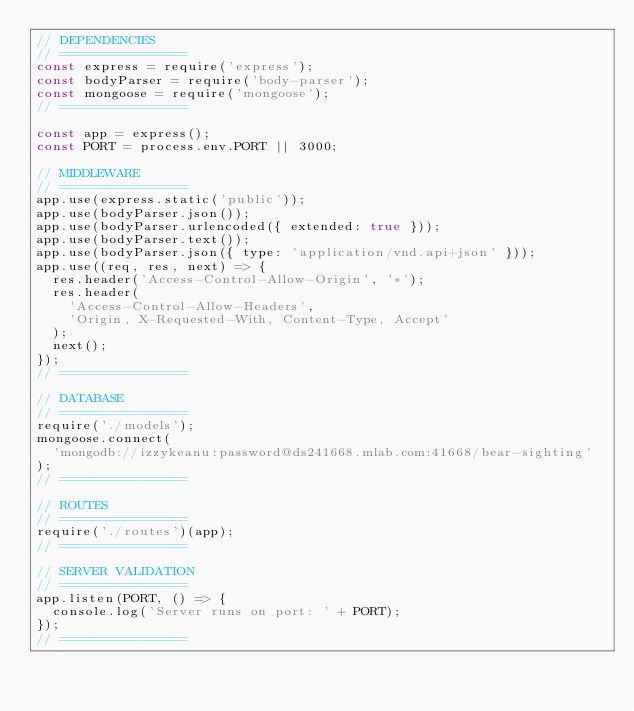<code> <loc_0><loc_0><loc_500><loc_500><_JavaScript_>// DEPENDENCIES
// ================
const express = require('express');
const bodyParser = require('body-parser');
const mongoose = require('mongoose');
// ================

const app = express();
const PORT = process.env.PORT || 3000;

// MIDDLEWARE
// ================
app.use(express.static('public'));
app.use(bodyParser.json());
app.use(bodyParser.urlencoded({ extended: true }));
app.use(bodyParser.text());
app.use(bodyParser.json({ type: 'application/vnd.api+json' }));
app.use((req, res, next) => {
  res.header('Access-Control-Allow-Origin', '*');
  res.header(
    'Access-Control-Allow-Headers',
    'Origin, X-Requested-With, Content-Type, Accept'
  );
  next();
});
// ================

// DATABASE
// ================
require('./models');
mongoose.connect(
  'mongodb://izzykeanu:password@ds241668.mlab.com:41668/bear-sighting'
);
// ================

// ROUTES
// ================
require('./routes')(app);
// ================

// SERVER VALIDATION
// ================
app.listen(PORT, () => {
  console.log('Server runs on port: ' + PORT);
});
// ================
</code> 